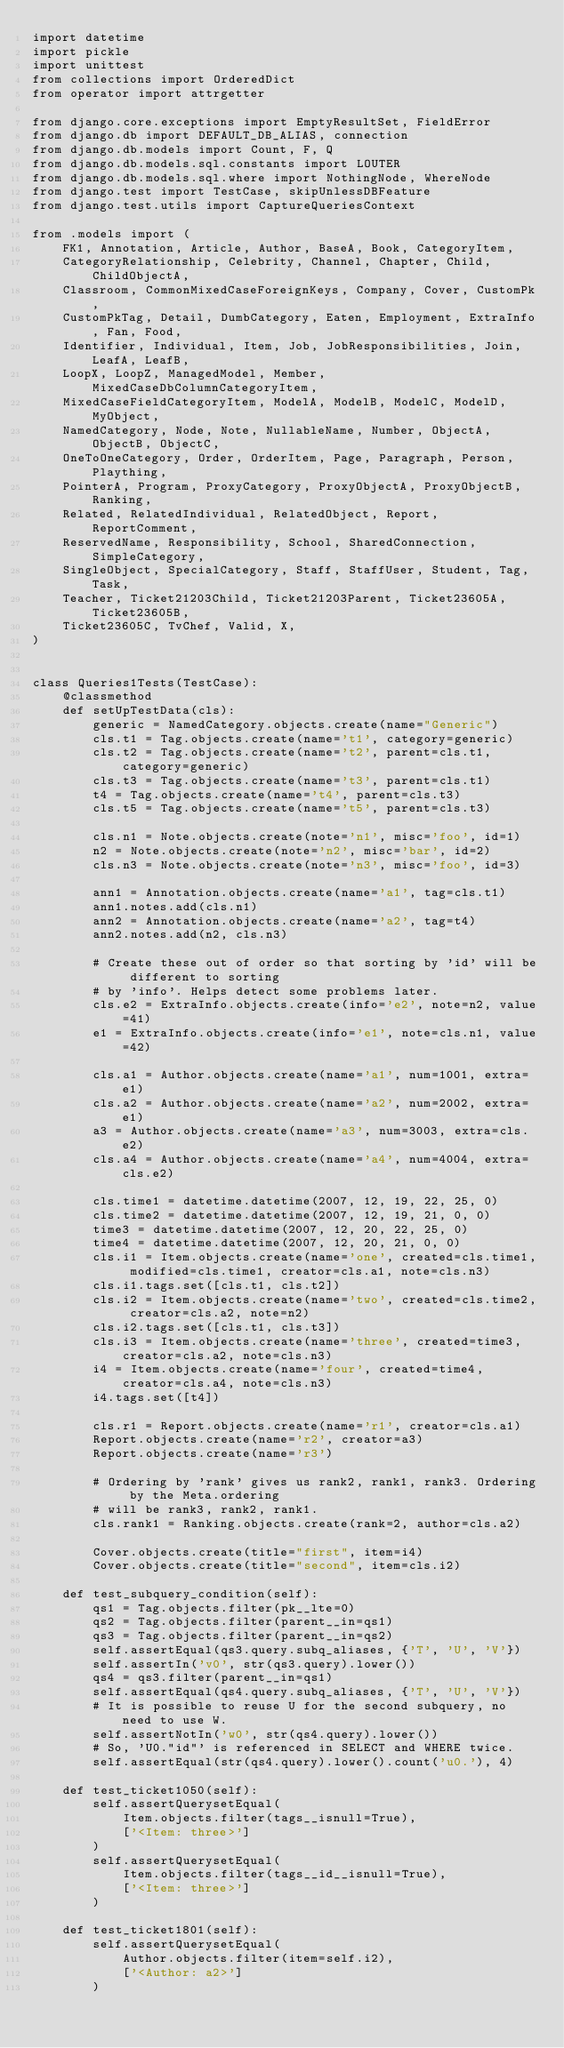<code> <loc_0><loc_0><loc_500><loc_500><_Python_>import datetime
import pickle
import unittest
from collections import OrderedDict
from operator import attrgetter

from django.core.exceptions import EmptyResultSet, FieldError
from django.db import DEFAULT_DB_ALIAS, connection
from django.db.models import Count, F, Q
from django.db.models.sql.constants import LOUTER
from django.db.models.sql.where import NothingNode, WhereNode
from django.test import TestCase, skipUnlessDBFeature
from django.test.utils import CaptureQueriesContext

from .models import (
    FK1, Annotation, Article, Author, BaseA, Book, CategoryItem,
    CategoryRelationship, Celebrity, Channel, Chapter, Child, ChildObjectA,
    Classroom, CommonMixedCaseForeignKeys, Company, Cover, CustomPk,
    CustomPkTag, Detail, DumbCategory, Eaten, Employment, ExtraInfo, Fan, Food,
    Identifier, Individual, Item, Job, JobResponsibilities, Join, LeafA, LeafB,
    LoopX, LoopZ, ManagedModel, Member, MixedCaseDbColumnCategoryItem,
    MixedCaseFieldCategoryItem, ModelA, ModelB, ModelC, ModelD, MyObject,
    NamedCategory, Node, Note, NullableName, Number, ObjectA, ObjectB, ObjectC,
    OneToOneCategory, Order, OrderItem, Page, Paragraph, Person, Plaything,
    PointerA, Program, ProxyCategory, ProxyObjectA, ProxyObjectB, Ranking,
    Related, RelatedIndividual, RelatedObject, Report, ReportComment,
    ReservedName, Responsibility, School, SharedConnection, SimpleCategory,
    SingleObject, SpecialCategory, Staff, StaffUser, Student, Tag, Task,
    Teacher, Ticket21203Child, Ticket21203Parent, Ticket23605A, Ticket23605B,
    Ticket23605C, TvChef, Valid, X,
)


class Queries1Tests(TestCase):
    @classmethod
    def setUpTestData(cls):
        generic = NamedCategory.objects.create(name="Generic")
        cls.t1 = Tag.objects.create(name='t1', category=generic)
        cls.t2 = Tag.objects.create(name='t2', parent=cls.t1, category=generic)
        cls.t3 = Tag.objects.create(name='t3', parent=cls.t1)
        t4 = Tag.objects.create(name='t4', parent=cls.t3)
        cls.t5 = Tag.objects.create(name='t5', parent=cls.t3)

        cls.n1 = Note.objects.create(note='n1', misc='foo', id=1)
        n2 = Note.objects.create(note='n2', misc='bar', id=2)
        cls.n3 = Note.objects.create(note='n3', misc='foo', id=3)

        ann1 = Annotation.objects.create(name='a1', tag=cls.t1)
        ann1.notes.add(cls.n1)
        ann2 = Annotation.objects.create(name='a2', tag=t4)
        ann2.notes.add(n2, cls.n3)

        # Create these out of order so that sorting by 'id' will be different to sorting
        # by 'info'. Helps detect some problems later.
        cls.e2 = ExtraInfo.objects.create(info='e2', note=n2, value=41)
        e1 = ExtraInfo.objects.create(info='e1', note=cls.n1, value=42)

        cls.a1 = Author.objects.create(name='a1', num=1001, extra=e1)
        cls.a2 = Author.objects.create(name='a2', num=2002, extra=e1)
        a3 = Author.objects.create(name='a3', num=3003, extra=cls.e2)
        cls.a4 = Author.objects.create(name='a4', num=4004, extra=cls.e2)

        cls.time1 = datetime.datetime(2007, 12, 19, 22, 25, 0)
        cls.time2 = datetime.datetime(2007, 12, 19, 21, 0, 0)
        time3 = datetime.datetime(2007, 12, 20, 22, 25, 0)
        time4 = datetime.datetime(2007, 12, 20, 21, 0, 0)
        cls.i1 = Item.objects.create(name='one', created=cls.time1, modified=cls.time1, creator=cls.a1, note=cls.n3)
        cls.i1.tags.set([cls.t1, cls.t2])
        cls.i2 = Item.objects.create(name='two', created=cls.time2, creator=cls.a2, note=n2)
        cls.i2.tags.set([cls.t1, cls.t3])
        cls.i3 = Item.objects.create(name='three', created=time3, creator=cls.a2, note=cls.n3)
        i4 = Item.objects.create(name='four', created=time4, creator=cls.a4, note=cls.n3)
        i4.tags.set([t4])

        cls.r1 = Report.objects.create(name='r1', creator=cls.a1)
        Report.objects.create(name='r2', creator=a3)
        Report.objects.create(name='r3')

        # Ordering by 'rank' gives us rank2, rank1, rank3. Ordering by the Meta.ordering
        # will be rank3, rank2, rank1.
        cls.rank1 = Ranking.objects.create(rank=2, author=cls.a2)

        Cover.objects.create(title="first", item=i4)
        Cover.objects.create(title="second", item=cls.i2)

    def test_subquery_condition(self):
        qs1 = Tag.objects.filter(pk__lte=0)
        qs2 = Tag.objects.filter(parent__in=qs1)
        qs3 = Tag.objects.filter(parent__in=qs2)
        self.assertEqual(qs3.query.subq_aliases, {'T', 'U', 'V'})
        self.assertIn('v0', str(qs3.query).lower())
        qs4 = qs3.filter(parent__in=qs1)
        self.assertEqual(qs4.query.subq_aliases, {'T', 'U', 'V'})
        # It is possible to reuse U for the second subquery, no need to use W.
        self.assertNotIn('w0', str(qs4.query).lower())
        # So, 'U0."id"' is referenced in SELECT and WHERE twice.
        self.assertEqual(str(qs4.query).lower().count('u0.'), 4)

    def test_ticket1050(self):
        self.assertQuerysetEqual(
            Item.objects.filter(tags__isnull=True),
            ['<Item: three>']
        )
        self.assertQuerysetEqual(
            Item.objects.filter(tags__id__isnull=True),
            ['<Item: three>']
        )

    def test_ticket1801(self):
        self.assertQuerysetEqual(
            Author.objects.filter(item=self.i2),
            ['<Author: a2>']
        )</code> 